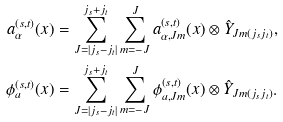<formula> <loc_0><loc_0><loc_500><loc_500>a _ { \alpha } ^ { ( s , t ) } ( x ) & = \sum _ { J = | j _ { s } - j _ { t } | } ^ { j _ { s } + j _ { t } } \sum _ { m = - J } ^ { J } a _ { \alpha , J m } ^ { ( s , t ) } ( x ) \otimes \hat { Y } _ { J m ( j _ { s } j _ { t } ) } , \\ \phi _ { a } ^ { ( s , t ) } ( x ) & = \sum _ { J = | j _ { s } - j _ { t } | } ^ { j _ { s } + j _ { t } } \sum _ { m = - J } ^ { J } \phi _ { a , J m } ^ { ( s , t ) } ( x ) \otimes \hat { Y } _ { J m ( j _ { s } j _ { t } ) } .</formula> 